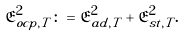<formula> <loc_0><loc_0><loc_500><loc_500>\mathfrak { E } _ { o c p , T } ^ { 2 } \colon = \mathfrak { E } _ { a d , T } ^ { 2 } + \mathfrak { E } _ { s t , T } ^ { 2 } .</formula> 